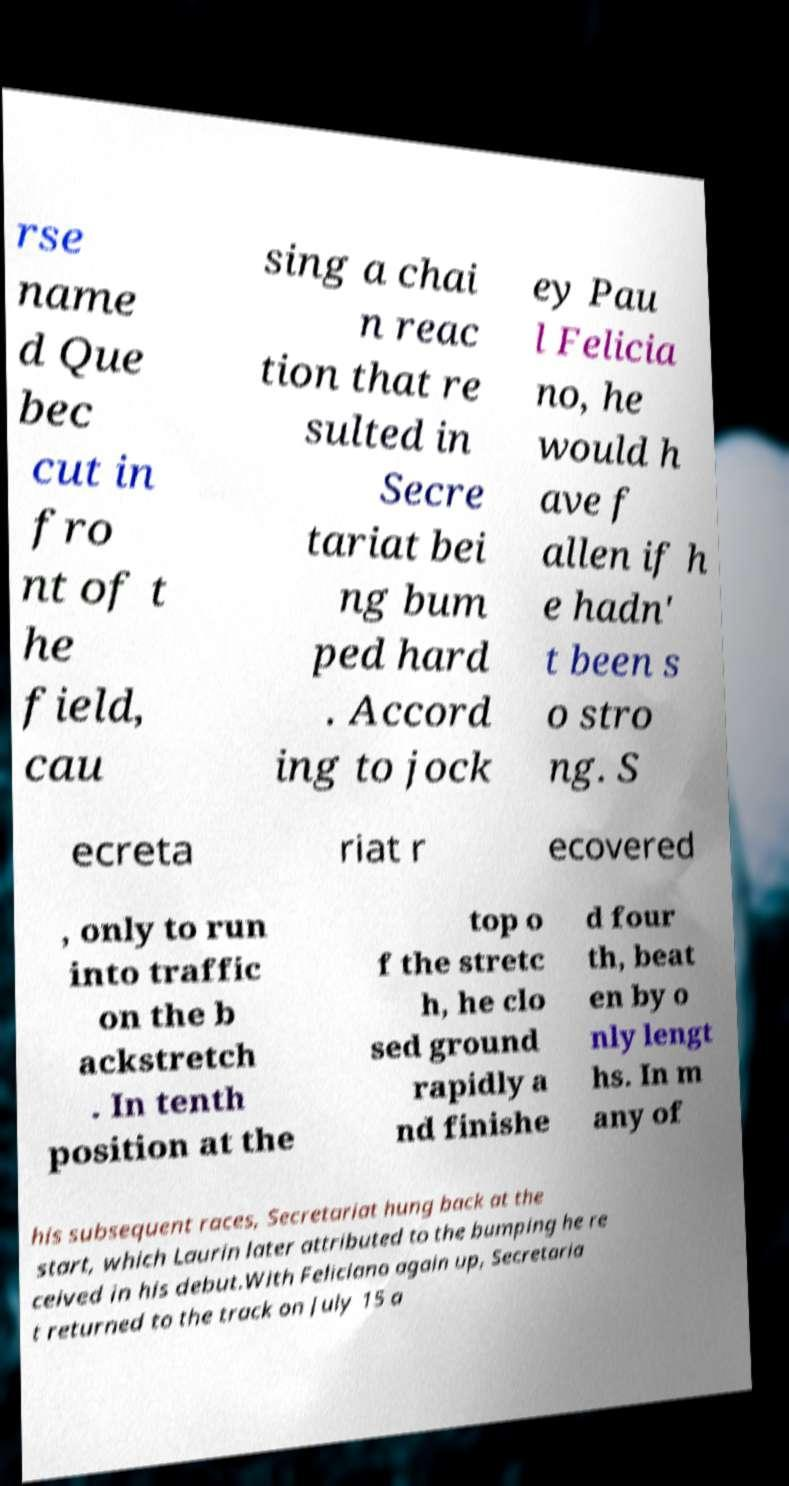Can you read and provide the text displayed in the image?This photo seems to have some interesting text. Can you extract and type it out for me? rse name d Que bec cut in fro nt of t he field, cau sing a chai n reac tion that re sulted in Secre tariat bei ng bum ped hard . Accord ing to jock ey Pau l Felicia no, he would h ave f allen if h e hadn' t been s o stro ng. S ecreta riat r ecovered , only to run into traffic on the b ackstretch . In tenth position at the top o f the stretc h, he clo sed ground rapidly a nd finishe d four th, beat en by o nly lengt hs. In m any of his subsequent races, Secretariat hung back at the start, which Laurin later attributed to the bumping he re ceived in his debut.With Feliciano again up, Secretaria t returned to the track on July 15 a 